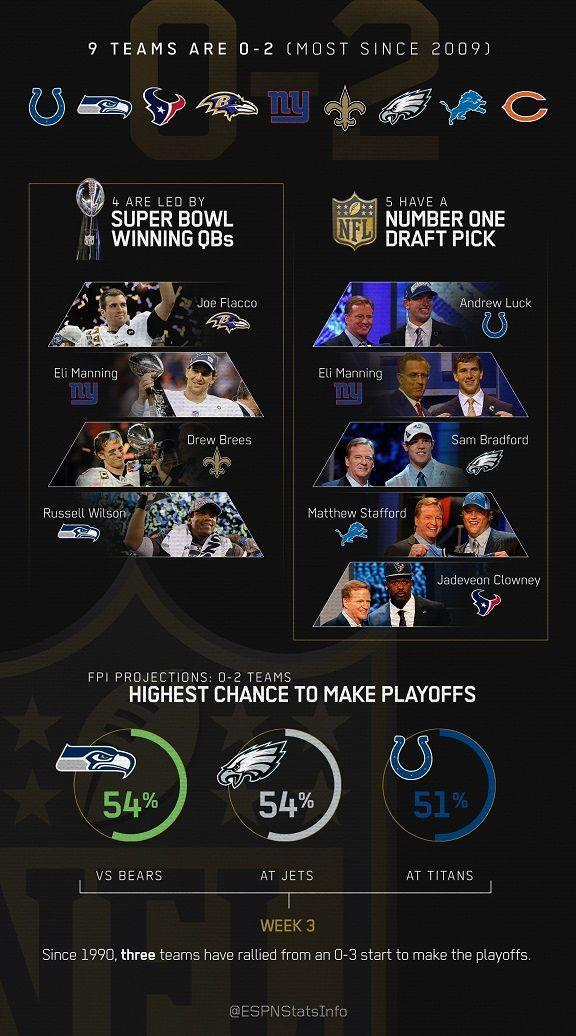Eli Manning belongs to which category of players?
Answer the question with a short phrase. Number One Draft Pick 